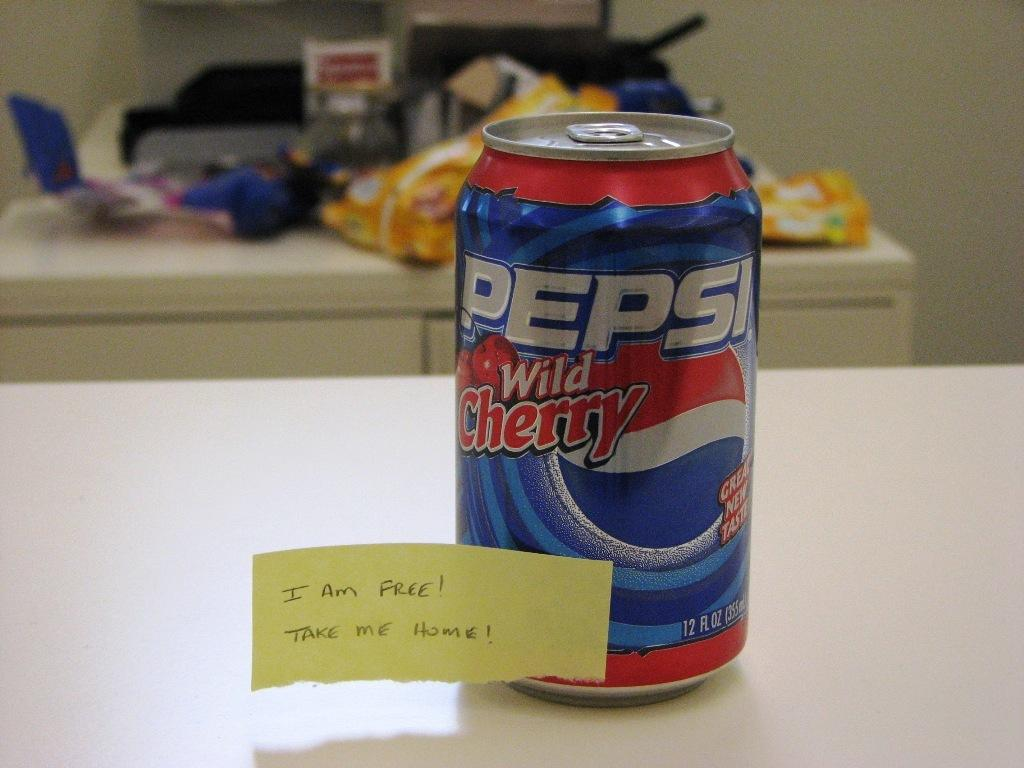<image>
Describe the image concisely. Someone has added a note to a can of Pepsi that says "I am free!" 